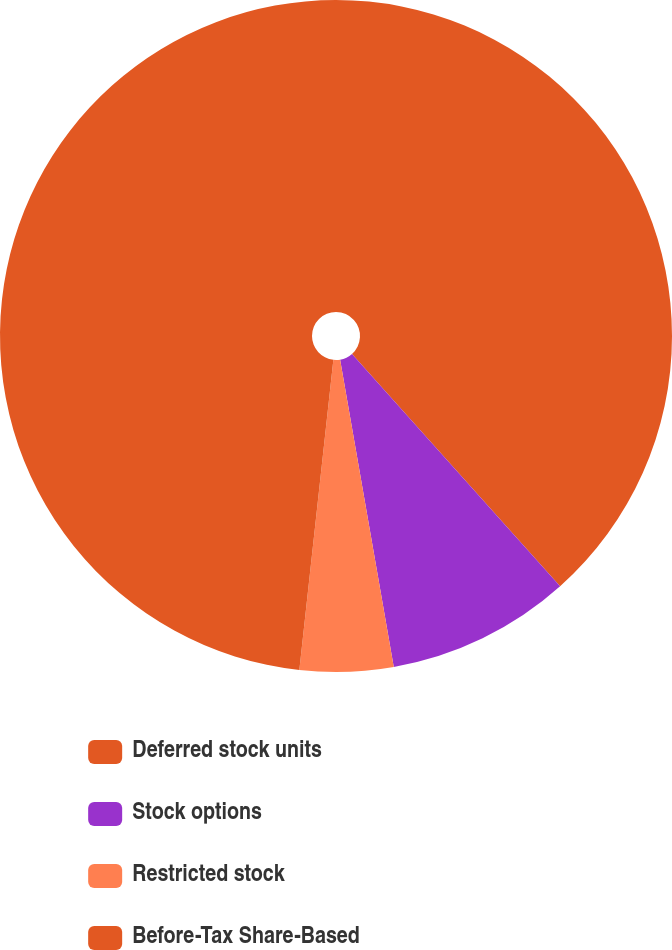<chart> <loc_0><loc_0><loc_500><loc_500><pie_chart><fcel>Deferred stock units<fcel>Stock options<fcel>Restricted stock<fcel>Before-Tax Share-Based<nl><fcel>38.38%<fcel>8.87%<fcel>4.49%<fcel>48.26%<nl></chart> 